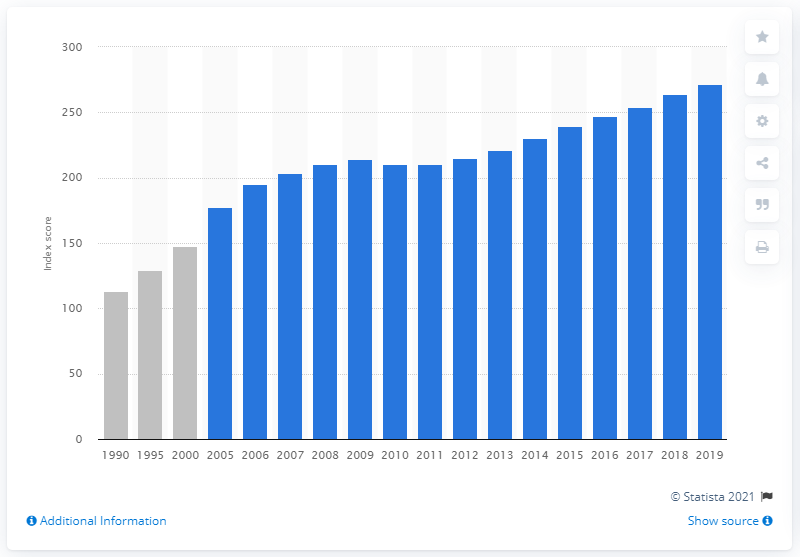Specify some key components in this picture. In 2019, the producer price index for concrete products was 271.7. 